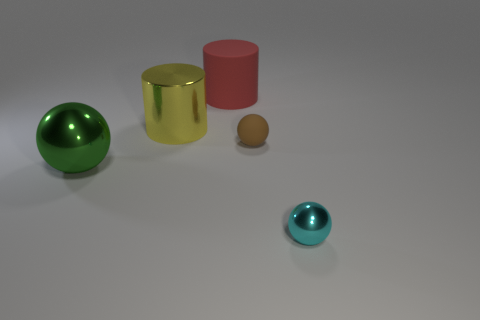How many yellow things are either matte objects or shiny objects?
Your answer should be very brief. 1. There is a metallic sphere to the left of the ball right of the brown object; what color is it?
Offer a very short reply. Green. What color is the large object in front of the brown matte thing?
Offer a very short reply. Green. Is the size of the metal sphere to the left of the yellow metallic cylinder the same as the brown object?
Give a very brief answer. No. Are there any things of the same size as the cyan ball?
Give a very brief answer. Yes. What number of other things are there of the same shape as the brown matte object?
Ensure brevity in your answer.  2. What shape is the metal thing behind the small brown object?
Give a very brief answer. Cylinder. There is a cyan shiny thing; does it have the same shape as the large metal thing in front of the rubber ball?
Keep it short and to the point. Yes. How big is the metal thing that is both in front of the brown object and to the right of the large green object?
Offer a terse response. Small. The metal object that is in front of the yellow thing and on the left side of the tiny rubber ball is what color?
Make the answer very short. Green. 